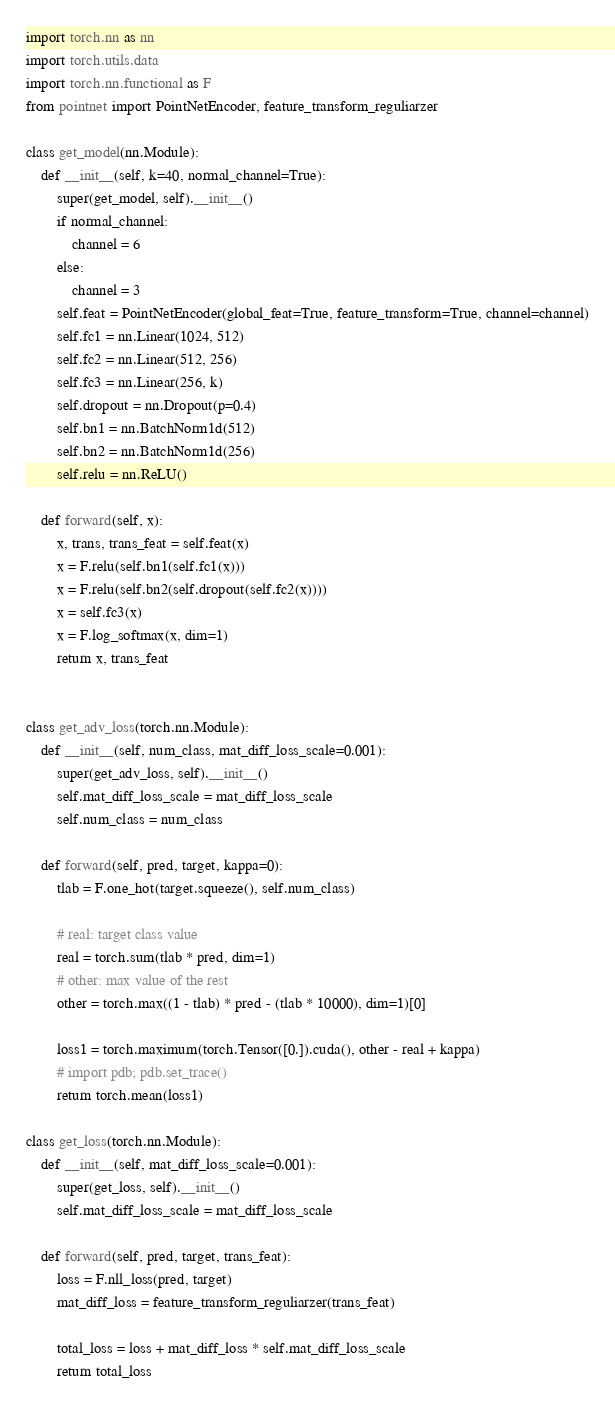<code> <loc_0><loc_0><loc_500><loc_500><_Python_>import torch.nn as nn
import torch.utils.data
import torch.nn.functional as F
from pointnet import PointNetEncoder, feature_transform_reguliarzer

class get_model(nn.Module):
    def __init__(self, k=40, normal_channel=True):
        super(get_model, self).__init__()
        if normal_channel:
            channel = 6
        else:
            channel = 3
        self.feat = PointNetEncoder(global_feat=True, feature_transform=True, channel=channel)
        self.fc1 = nn.Linear(1024, 512)
        self.fc2 = nn.Linear(512, 256)
        self.fc3 = nn.Linear(256, k)
        self.dropout = nn.Dropout(p=0.4)
        self.bn1 = nn.BatchNorm1d(512)
        self.bn2 = nn.BatchNorm1d(256)
        self.relu = nn.ReLU()

    def forward(self, x):
        x, trans, trans_feat = self.feat(x)
        x = F.relu(self.bn1(self.fc1(x)))
        x = F.relu(self.bn2(self.dropout(self.fc2(x))))
        x = self.fc3(x)
        x = F.log_softmax(x, dim=1)
        return x, trans_feat


class get_adv_loss(torch.nn.Module):
    def __init__(self, num_class, mat_diff_loss_scale=0.001):
        super(get_adv_loss, self).__init__()
        self.mat_diff_loss_scale = mat_diff_loss_scale
        self.num_class = num_class

    def forward(self, pred, target, kappa=0):
        tlab = F.one_hot(target.squeeze(), self.num_class)

        # real: target class value
        real = torch.sum(tlab * pred, dim=1)
        # other: max value of the rest
        other = torch.max((1 - tlab) * pred - (tlab * 10000), dim=1)[0]

        loss1 = torch.maximum(torch.Tensor([0.]).cuda(), other - real + kappa)
        # import pdb; pdb.set_trace()
        return torch.mean(loss1)

class get_loss(torch.nn.Module):
    def __init__(self, mat_diff_loss_scale=0.001):
        super(get_loss, self).__init__()
        self.mat_diff_loss_scale = mat_diff_loss_scale

    def forward(self, pred, target, trans_feat):
        loss = F.nll_loss(pred, target)
        mat_diff_loss = feature_transform_reguliarzer(trans_feat)

        total_loss = loss + mat_diff_loss * self.mat_diff_loss_scale
        return total_loss
</code> 